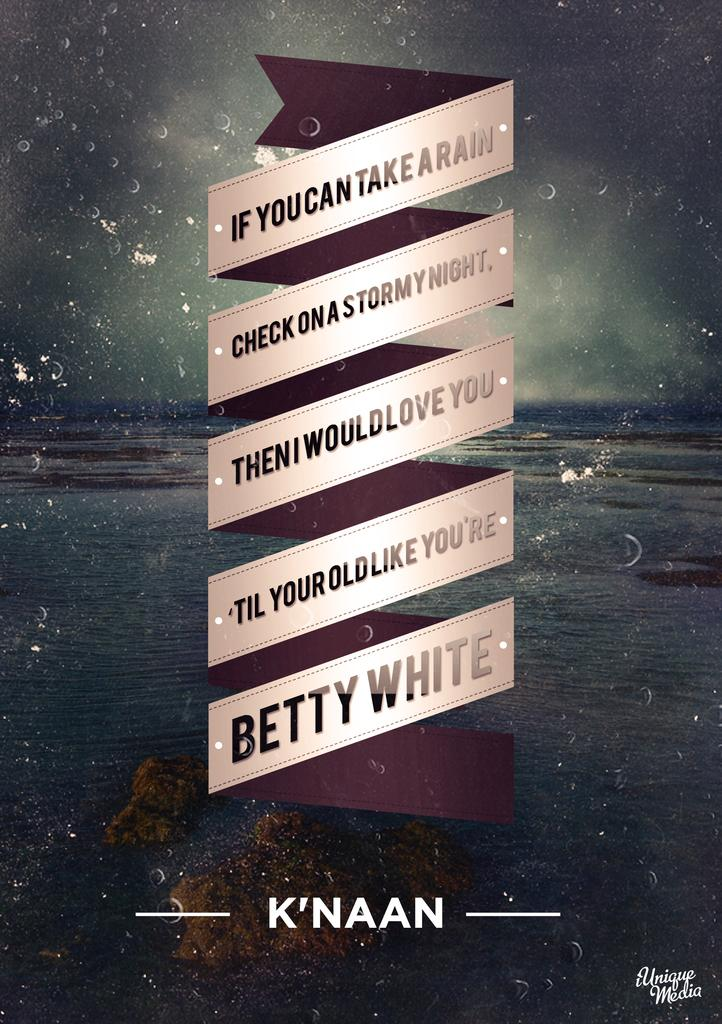<image>
Create a compact narrative representing the image presented. many signs with the name Betty White at the bottom 